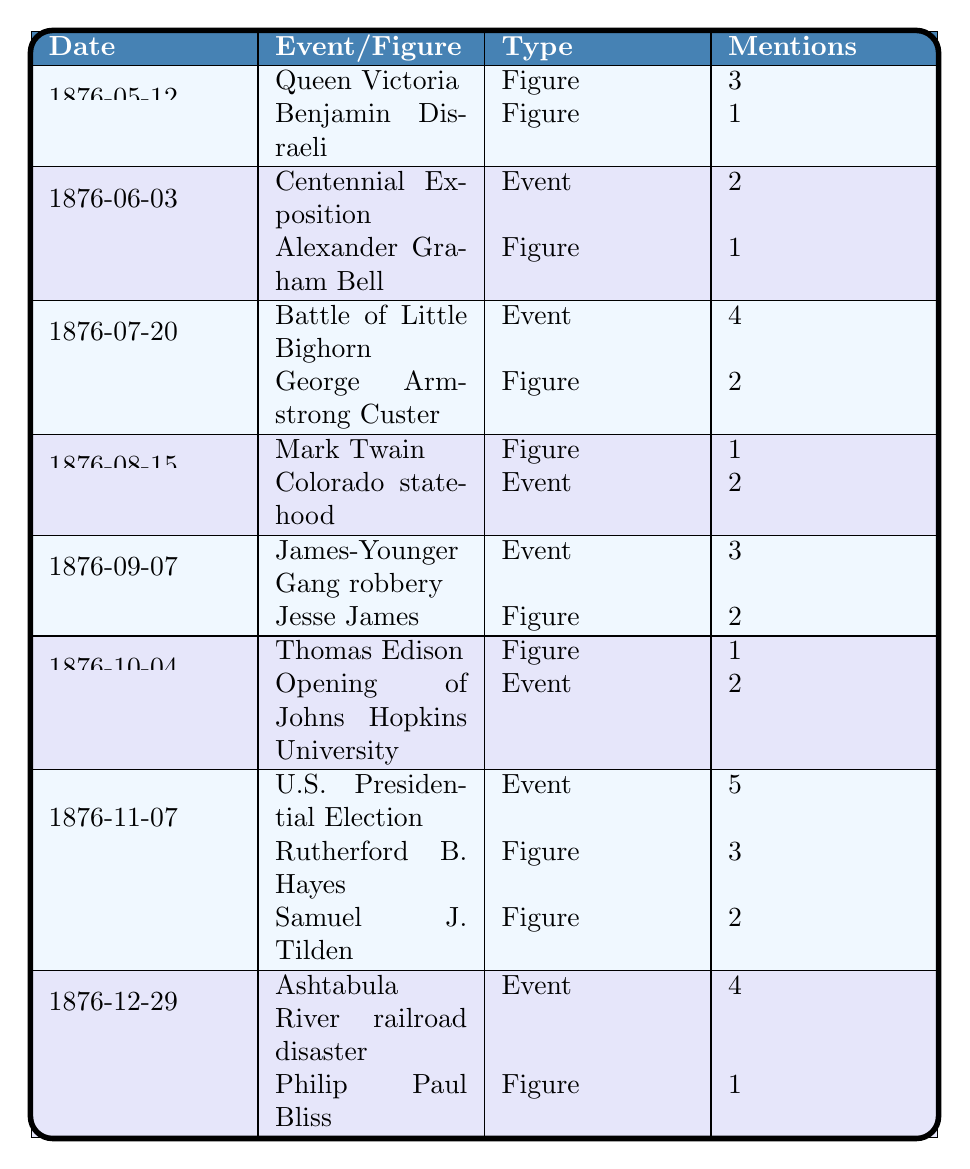What event is mentioned the most times in the diary? The U.S. Presidential Election on 1876-11-07 is mentioned 5 times, which is the highest count compared to other events.
Answer: U.S. Presidential Election How many times is Queen Victoria mentioned in total? Queen Victoria is mentioned 3 times on 1876-05-12, making her total mentions 3.
Answer: 3 Which figure was mentioned alongside the Battle of Little Bighorn? George Armstrong Custer was mentioned alongside the Battle of Little Bighorn and is listed with 2 mentions.
Answer: George Armstrong Custer What is the total count of mentions for events in October 1876? In October 1876, 'Opening of Johns Hopkins University' is mentioned 2 times; the total for that month is 2.
Answer: 2 Which figure was mentioned the least number of times? Thomas Edison is the least mentioned figure, with only 1 mention recorded on 1876-10-04.
Answer: Thomas Edison Is there a diary entry with more mentions of figures than events? Yes, the entry on 1876-11-07 has 3 mentions of figures (Rutherford B. Hayes and Samuel J. Tilden) and 1 event (U.S. Presidential Election), totaling 4 mentions of figures.
Answer: Yes How many events were mentioned in the entire diary? The events mentioned are 'Centennial Exposition,' 'Battle of Little Bighorn,' 'Colorado statehood,' 'James-Younger Gang robbery,' 'U.S. Presidential Election,' 'Opening of Johns Hopkins University,' and 'Ashtabula River railroad disaster,' totaling 7 events.
Answer: 7 What is the average number of mentions per diary entry across the provided data? Counting all mentions (3+1+2+1+4+2+2+1+2+5+3+2+4+1 = 27) and there are 8 entries, the average mentions are 27/8 = 3.375, which can be rounded to 3.4.
Answer: 3.4 Which month has the highest total mentions across both figures and events? November 1876 has the highest total mentions with 10 (5 for the event U.S. Presidential Election and 3 and 2 for the figures).
Answer: November 1876 How many events mention the word "disaster"? The Ashtabula River railroad disaster is the only event that mentions "disaster."
Answer: 1 